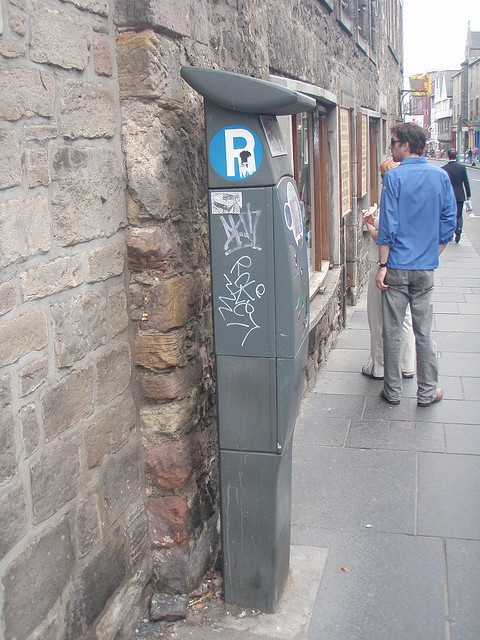Describe the objects in this image and their specific colors. I can see parking meter in lightgray, gray, and darkgray tones, people in lightgray, gray, and darkgray tones, people in lightgray, darkgray, and gray tones, people in lightgray, gray, navy, and darkblue tones, and people in lightgray, tan, gray, and darkgray tones in this image. 